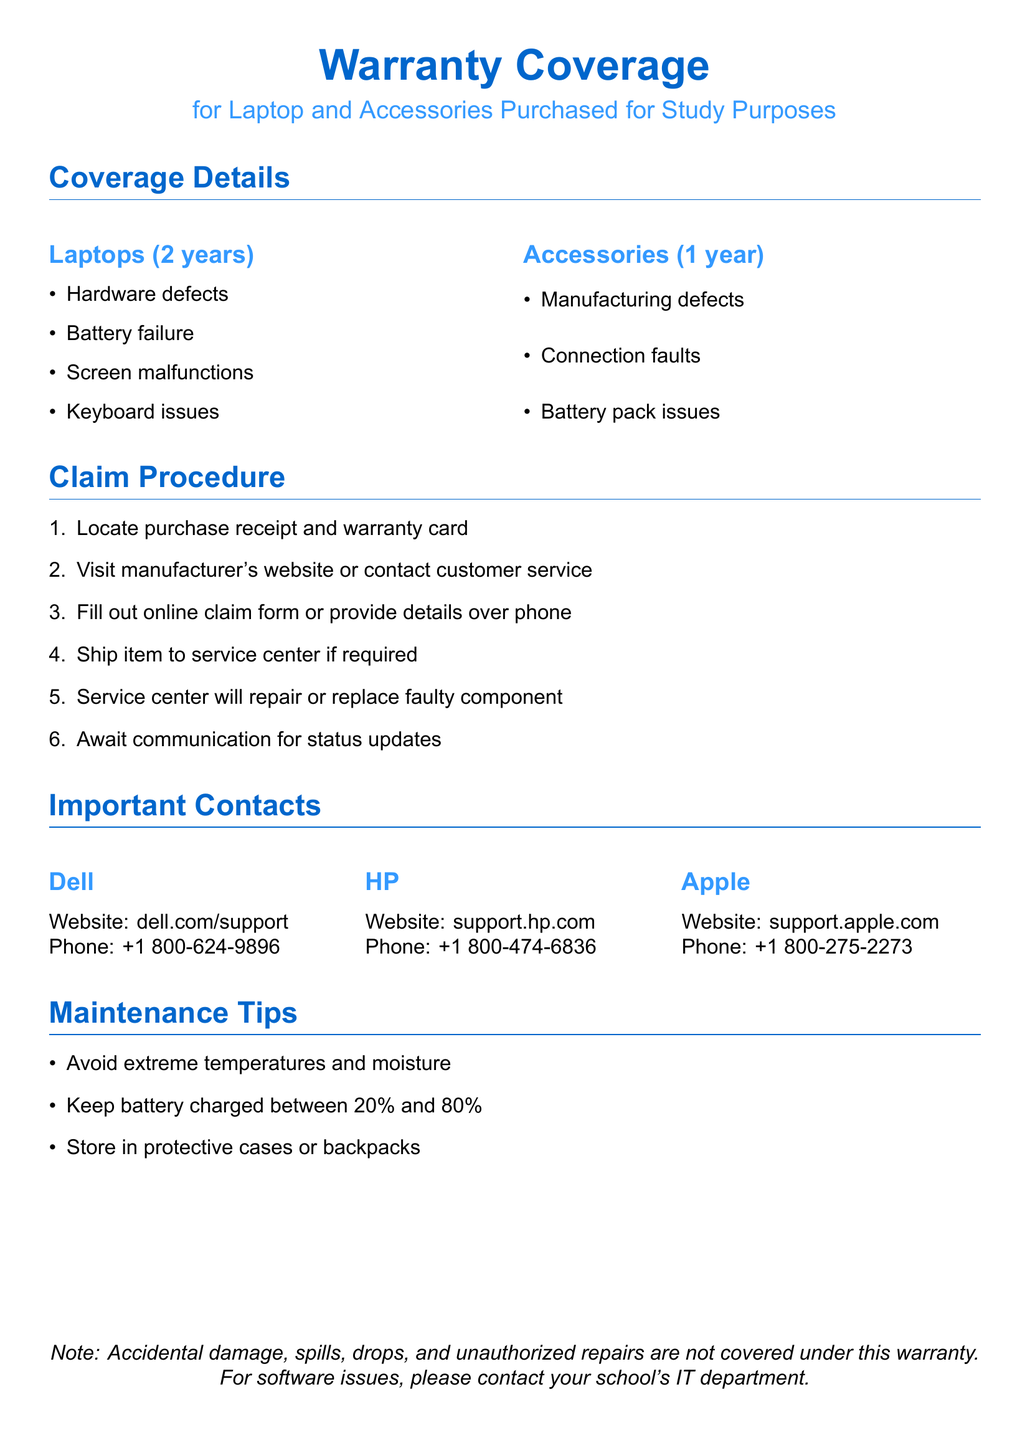what is the warranty period for laptops? The warranty period for laptops is specified in the document under coverage details.
Answer: 2 years what types of defects are covered for laptops? The document enumerates different types of defects for laptops listed under coverage details.
Answer: Hardware defects, Battery failure, Screen malfunctions, Keyboard issues how long is the warranty for accessories? The warranty period for accessories is mentioned in the coverage details section of the document.
Answer: 1 year what is the first step in the claim procedure? The claim procedure outlines specific steps to follow, and the first step is stated clearly.
Answer: Locate purchase receipt and warranty card which company's support contact information is listed first? The document lists important contacts for different companies, ordered by name.
Answer: Dell what types of issues are not covered under the warranty? The document specifies exclusions from the warranty coverage.
Answer: Accidental damage, spills, drops, and unauthorized repairs what should you keep the battery charged between? Maintenance tips in the document include battery care instructions, specifically charging recommendations.
Answer: 20% and 80% which website should you visit for HP support? The document provides specific web addresses for each company's support, particularly for HP.
Answer: support.hp.com what does the warranty not cover regarding software? The document makes it clear where to seek help for software-related issues not covered by the warranty.
Answer: IT department 